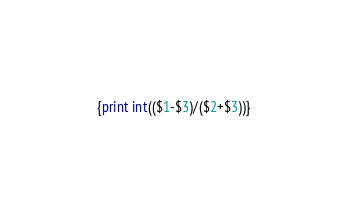<code> <loc_0><loc_0><loc_500><loc_500><_Awk_>{print int(($1-$3)/($2+$3))}</code> 